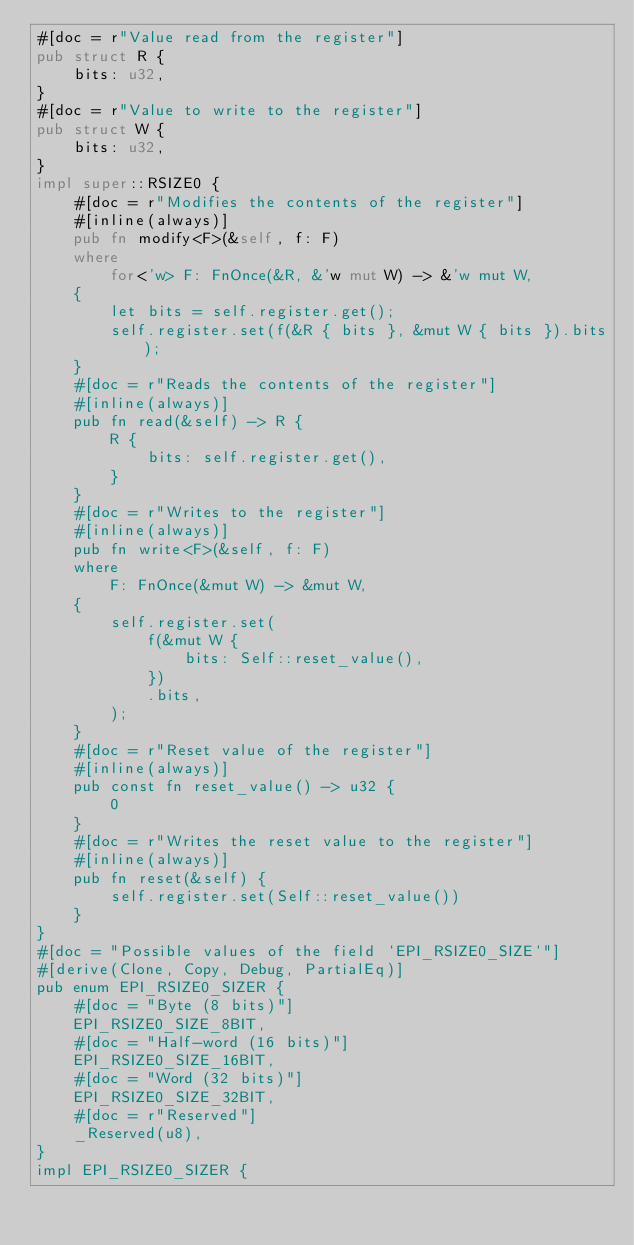<code> <loc_0><loc_0><loc_500><loc_500><_Rust_>#[doc = r"Value read from the register"]
pub struct R {
    bits: u32,
}
#[doc = r"Value to write to the register"]
pub struct W {
    bits: u32,
}
impl super::RSIZE0 {
    #[doc = r"Modifies the contents of the register"]
    #[inline(always)]
    pub fn modify<F>(&self, f: F)
    where
        for<'w> F: FnOnce(&R, &'w mut W) -> &'w mut W,
    {
        let bits = self.register.get();
        self.register.set(f(&R { bits }, &mut W { bits }).bits);
    }
    #[doc = r"Reads the contents of the register"]
    #[inline(always)]
    pub fn read(&self) -> R {
        R {
            bits: self.register.get(),
        }
    }
    #[doc = r"Writes to the register"]
    #[inline(always)]
    pub fn write<F>(&self, f: F)
    where
        F: FnOnce(&mut W) -> &mut W,
    {
        self.register.set(
            f(&mut W {
                bits: Self::reset_value(),
            })
            .bits,
        );
    }
    #[doc = r"Reset value of the register"]
    #[inline(always)]
    pub const fn reset_value() -> u32 {
        0
    }
    #[doc = r"Writes the reset value to the register"]
    #[inline(always)]
    pub fn reset(&self) {
        self.register.set(Self::reset_value())
    }
}
#[doc = "Possible values of the field `EPI_RSIZE0_SIZE`"]
#[derive(Clone, Copy, Debug, PartialEq)]
pub enum EPI_RSIZE0_SIZER {
    #[doc = "Byte (8 bits)"]
    EPI_RSIZE0_SIZE_8BIT,
    #[doc = "Half-word (16 bits)"]
    EPI_RSIZE0_SIZE_16BIT,
    #[doc = "Word (32 bits)"]
    EPI_RSIZE0_SIZE_32BIT,
    #[doc = r"Reserved"]
    _Reserved(u8),
}
impl EPI_RSIZE0_SIZER {</code> 